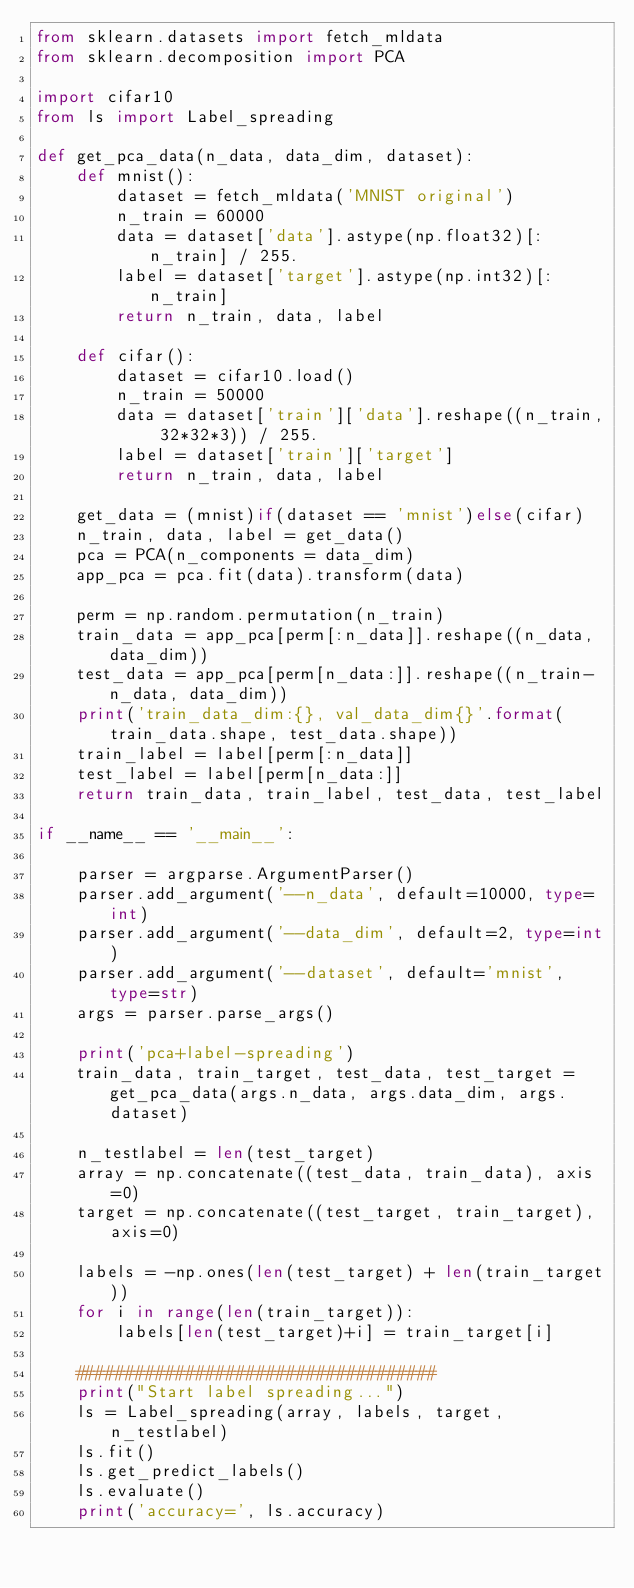Convert code to text. <code><loc_0><loc_0><loc_500><loc_500><_Python_>from sklearn.datasets import fetch_mldata
from sklearn.decomposition import PCA

import cifar10
from ls import Label_spreading

def get_pca_data(n_data, data_dim, dataset):
    def mnist():
        dataset = fetch_mldata('MNIST original')
        n_train = 60000
        data = dataset['data'].astype(np.float32)[:n_train] / 255.
        label = dataset['target'].astype(np.int32)[:n_train]
        return n_train, data, label
    
    def cifar():
        dataset = cifar10.load()
        n_train = 50000
        data = dataset['train']['data'].reshape((n_train, 32*32*3)) / 255.
        label = dataset['train']['target']
        return n_train, data, label
    
    get_data = (mnist)if(dataset == 'mnist')else(cifar)
    n_train, data, label = get_data() 
    pca = PCA(n_components = data_dim)
    app_pca = pca.fit(data).transform(data)
    
    perm = np.random.permutation(n_train)
    train_data = app_pca[perm[:n_data]].reshape((n_data, data_dim))
    test_data = app_pca[perm[n_data:]].reshape((n_train-n_data, data_dim))
    print('train_data_dim:{}, val_data_dim{}'.format(train_data.shape, test_data.shape))
    train_label = label[perm[:n_data]]
    test_label = label[perm[n_data:]]
    return train_data, train_label, test_data, test_label

if __name__ == '__main__':

    parser = argparse.ArgumentParser()
    parser.add_argument('--n_data', default=10000, type=int)
    parser.add_argument('--data_dim', default=2, type=int)
    parser.add_argument('--dataset', default='mnist', type=str)
    args = parser.parse_args()
    
    print('pca+label-spreading')
    train_data, train_target, test_data, test_target = get_pca_data(args.n_data, args.data_dim, args.dataset)
    
    n_testlabel = len(test_target)
    array = np.concatenate((test_data, train_data), axis=0)
    target = np.concatenate((test_target, train_target), axis=0)
    
    labels = -np.ones(len(test_target) + len(train_target))
    for i in range(len(train_target)):
        labels[len(test_target)+i] = train_target[i]
    
    ####################################
    print("Start label spreading...")
    ls = Label_spreading(array, labels, target, n_testlabel)
    ls.fit()
    ls.get_predict_labels()
    ls.evaluate()
    print('accuracy=', ls.accuracy)   
</code> 